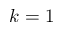<formula> <loc_0><loc_0><loc_500><loc_500>k = 1</formula> 